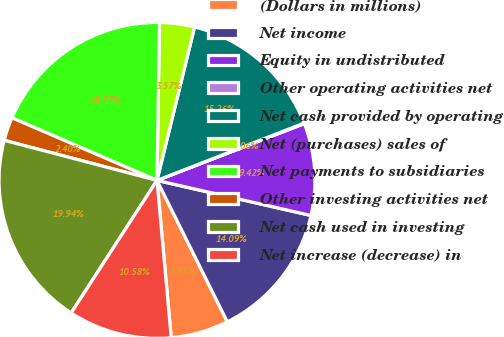<chart> <loc_0><loc_0><loc_500><loc_500><pie_chart><fcel>(Dollars in millions)<fcel>Net income<fcel>Equity in undistributed<fcel>Other operating activities net<fcel>Net cash provided by operating<fcel>Net (purchases) sales of<fcel>Net payments to subsidiaries<fcel>Other investing activities net<fcel>Net cash used in investing<fcel>Net increase (decrease) in<nl><fcel>5.91%<fcel>14.09%<fcel>9.42%<fcel>0.06%<fcel>15.26%<fcel>3.57%<fcel>18.77%<fcel>2.4%<fcel>19.94%<fcel>10.58%<nl></chart> 